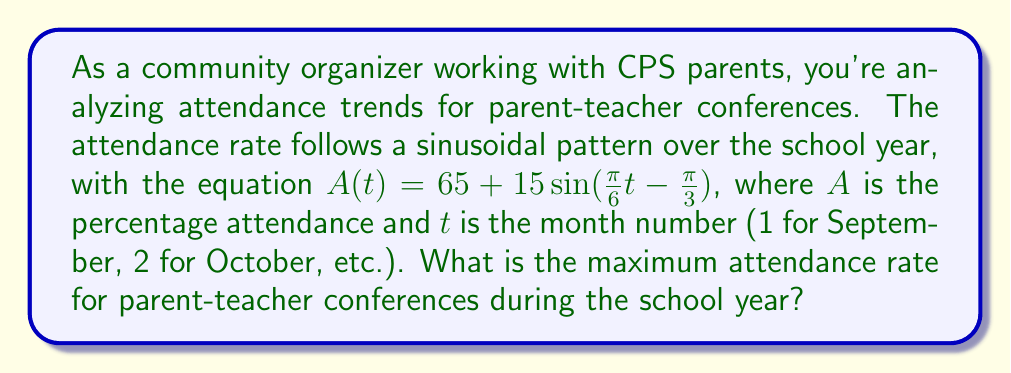Can you solve this math problem? To find the maximum attendance rate, we need to analyze the sinusoidal function:

$A(t) = 65 + 15\sin(\frac{\pi}{6}t - \frac{\pi}{3})$

1. Identify the components of the function:
   - Midline: 65%
   - Amplitude: 15%
   - Period: $\frac{2\pi}{\frac{\pi}{6}} = 12$ months
   - Phase shift: $\frac{2}{\pi} \cdot \frac{\pi}{3} = 2$ months

2. The maximum value of a sine function occurs when the argument of sine equals $\frac{\pi}{2}$ (or 90°).

3. Set up the equation:
   $\frac{\pi}{6}t - \frac{\pi}{3} = \frac{\pi}{2}$

4. Solve for t:
   $\frac{\pi}{6}t = \frac{\pi}{2} + \frac{\pi}{3}$
   $\frac{\pi}{6}t = \frac{5\pi}{6}$
   $t = 5$

5. The maximum occurs 5 months after the start of the school year (January).

6. Calculate the maximum value:
   $A_{max} = 65 + 15\sin(\frac{\pi}{6} \cdot 5 - \frac{\pi}{3})$
   $A_{max} = 65 + 15\sin(\frac{5\pi}{6} - \frac{\pi}{3})$
   $A_{max} = 65 + 15\sin(\frac{\pi}{2})$
   $A_{max} = 65 + 15 = 80$

Therefore, the maximum attendance rate is 80%.
Answer: 80% 